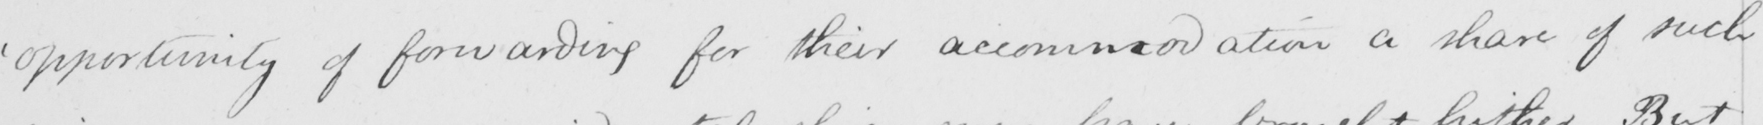What does this handwritten line say? ' opportunity of forwarding for their accommodation a share of such 